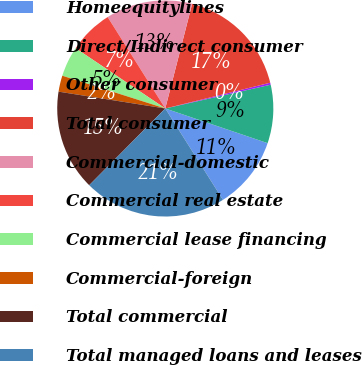Convert chart to OTSL. <chart><loc_0><loc_0><loc_500><loc_500><pie_chart><fcel>Homeequitylines<fcel>Direct/Indirect consumer<fcel>Other consumer<fcel>Total consumer<fcel>Commercial-domestic<fcel>Commercial real estate<fcel>Commercial lease financing<fcel>Commercial-foreign<fcel>Total commercial<fcel>Total managed loans and leases<nl><fcel>10.84%<fcel>8.73%<fcel>0.3%<fcel>17.17%<fcel>12.95%<fcel>6.63%<fcel>4.52%<fcel>2.41%<fcel>15.06%<fcel>21.39%<nl></chart> 